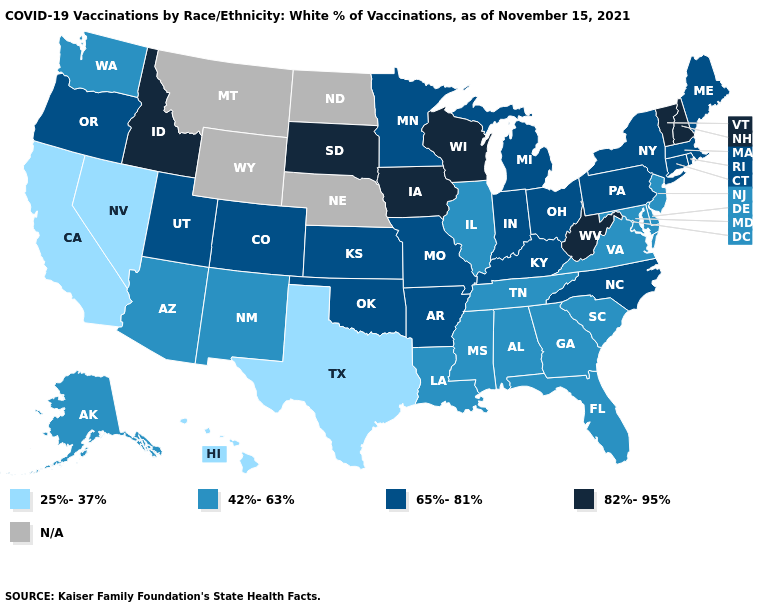Which states hav the highest value in the South?
Concise answer only. West Virginia. What is the lowest value in the USA?
Keep it brief. 25%-37%. Is the legend a continuous bar?
Give a very brief answer. No. What is the value of Texas?
Quick response, please. 25%-37%. What is the lowest value in states that border Kentucky?
Give a very brief answer. 42%-63%. Does the map have missing data?
Give a very brief answer. Yes. Does West Virginia have the highest value in the South?
Short answer required. Yes. Is the legend a continuous bar?
Quick response, please. No. What is the value of Iowa?
Be succinct. 82%-95%. Name the states that have a value in the range 25%-37%?
Quick response, please. California, Hawaii, Nevada, Texas. What is the value of Hawaii?
Concise answer only. 25%-37%. Name the states that have a value in the range 65%-81%?
Short answer required. Arkansas, Colorado, Connecticut, Indiana, Kansas, Kentucky, Maine, Massachusetts, Michigan, Minnesota, Missouri, New York, North Carolina, Ohio, Oklahoma, Oregon, Pennsylvania, Rhode Island, Utah. What is the value of Florida?
Short answer required. 42%-63%. 